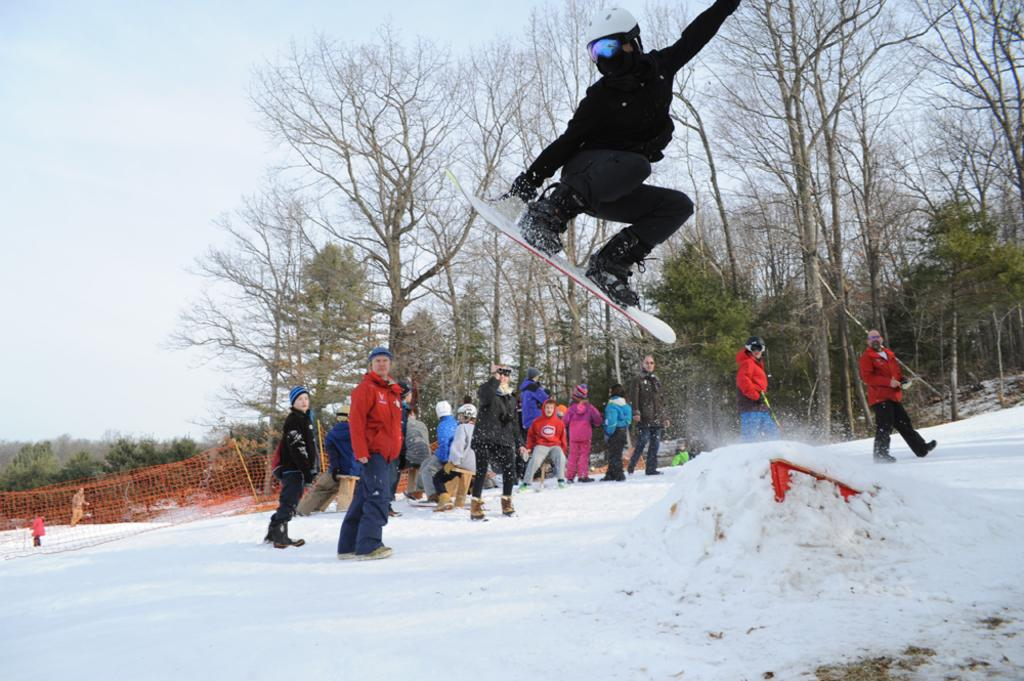What is the person in the image wearing? The person is wearing a black dress in the image. What is the person doing with their legs? The person has their legs on a ski. What is the position of the ski in the image? The ski is in the air. Are there any other people present in the image? Yes, there are other people standing beside the person. What can be seen in the background of the image? There are trees in the background of the image. What type of stew is being served to the person on the ski? There is no stew present in the image; the person is wearing a black dress and has their legs on a ski. What paper is the person holding while skiing? There is no paper present in the image; the person is focused on skiing with their legs on the ski. 